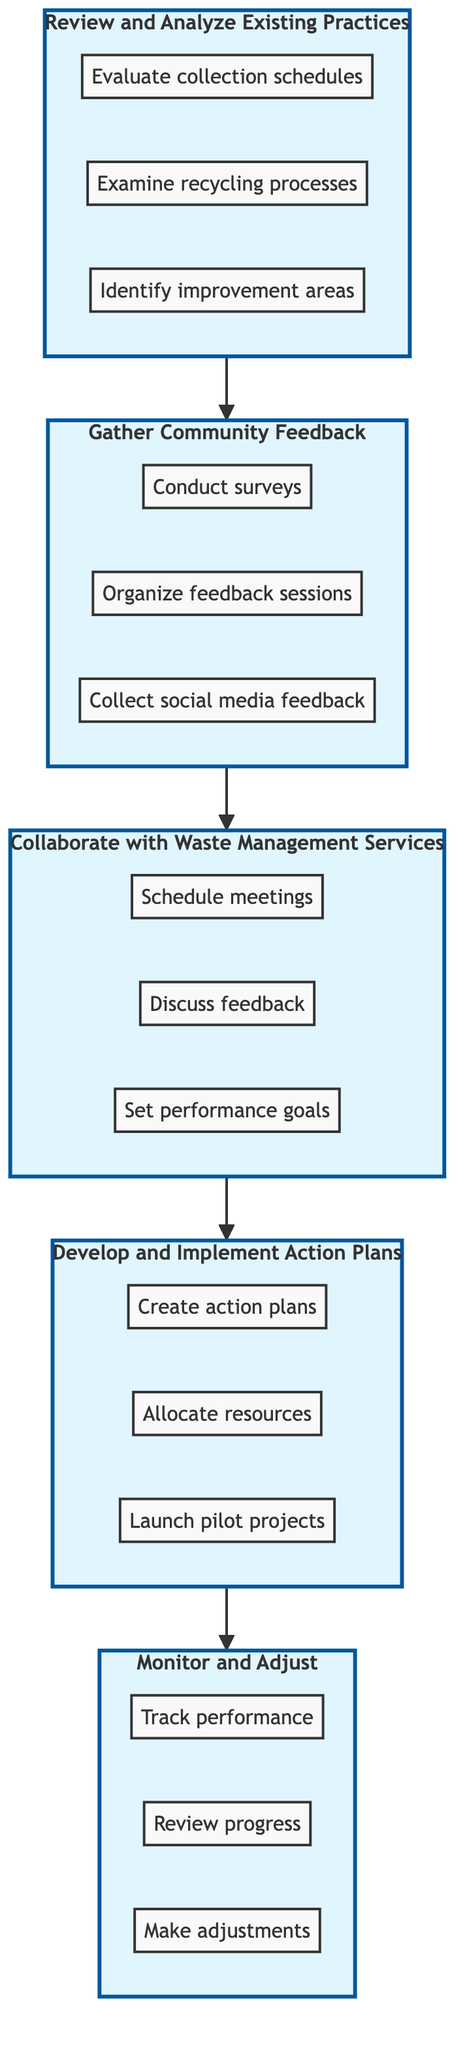What is the first step in the process? The diagram indicates that the first step is "Review and Analyze Existing Waste Management Practices." This is visually placed at the bottom and serves as the foundation for the subsequent steps.
Answer: Review and Analyze Existing Waste Management Practices How many main levels are there in the flowchart? There are five main levels illustrated in the flowchart that outline the process from bottom to top, indicating a stepwise approach to providing effective feedback.
Answer: 5 What is the action taken in the last step? The last step in the flowchart is "Make necessary adjustments," which shows the final action taken after monitoring progress.
Answer: Make necessary adjustments Which level includes "Schedule meetings with waste management professionals"? The action "Schedule meetings with waste management professionals" is included in Level 3, which focuses on collaboration with Waste Management Services.
Answer: Collaborate with Waste Management Services What is the relationship between "Gather Community Feedback" and "Develop and Implement Action Plans"? "Gather Community Feedback" is a prerequisite for "Develop and Implement Action Plans," indicating that feedback must be collected before an action plan can be created. This flow is shown with a directed connection moving upward in the diagram.
Answer: Prerequisite How do you go from gathering feedback to collaboration? To move from "Gather Community Feedback" to "Collaborate with Waste Management Services," one must first conduct surveys, organize feedback sessions, and collect social media feedback, leading to discussions with waste management professionals.
Answer: Conduct feedback activities first How many actions are listed under "Develop and Implement Action Plans"? Three distinct actions are listed under "Develop and Implement Action Plans," which are "Create detailed action plans," "Allocate resources for plan implementation," and "Launch pilot projects."
Answer: 3 What comes just before monitoring and adjusting? "Develop and Implement Action Plans" comes immediately before "Monitor and Adjust" in the flow of the diagram. This shows that monitoring follows implementation of plans to assess effectiveness.
Answer: Develop and Implement Action Plans What node directly leads to monitoring and adjusting? The node that directly leads to "Monitor and Adjust" is "Develop and Implement Action Plans," indicating that monitoring occurs only after action plans are executed.
Answer: Develop and Implement Action Plans 